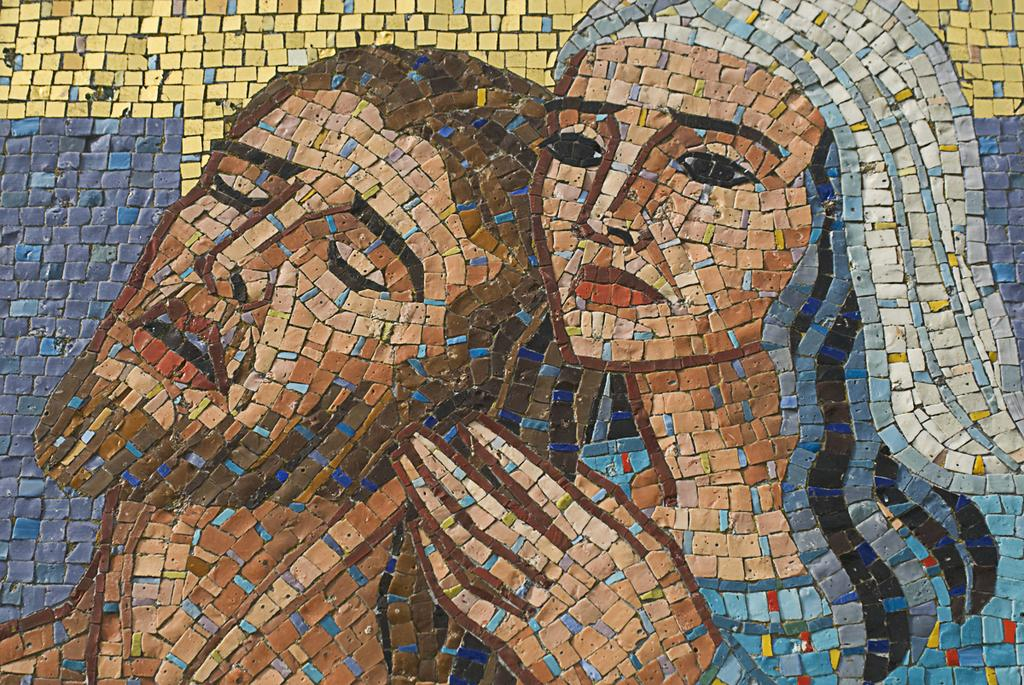What is hanging on the wall in the image? There is a painting on the wall in the image. What type of bait is being used by the beast in the image? There is no beast or bait present in the image; it only features a painting on the wall. 